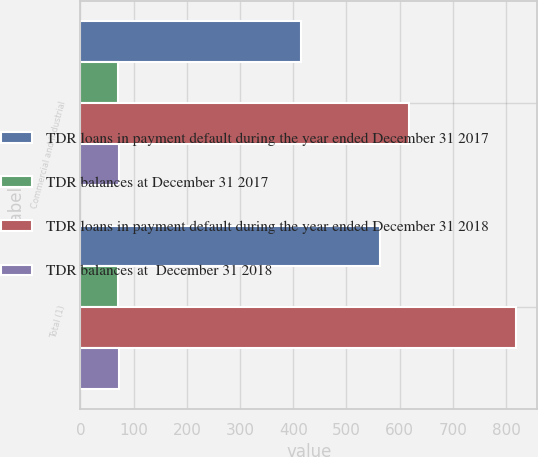Convert chart to OTSL. <chart><loc_0><loc_0><loc_500><loc_500><stacked_bar_chart><ecel><fcel>Commercial and industrial<fcel>Total (1)<nl><fcel>TDR loans in payment default during the year ended December 31 2017<fcel>414<fcel>564<nl><fcel>TDR balances at December 31 2017<fcel>70<fcel>70<nl><fcel>TDR loans in payment default during the year ended December 31 2018<fcel>617<fcel>818<nl><fcel>TDR balances at  December 31 2018<fcel>72<fcel>72<nl></chart> 